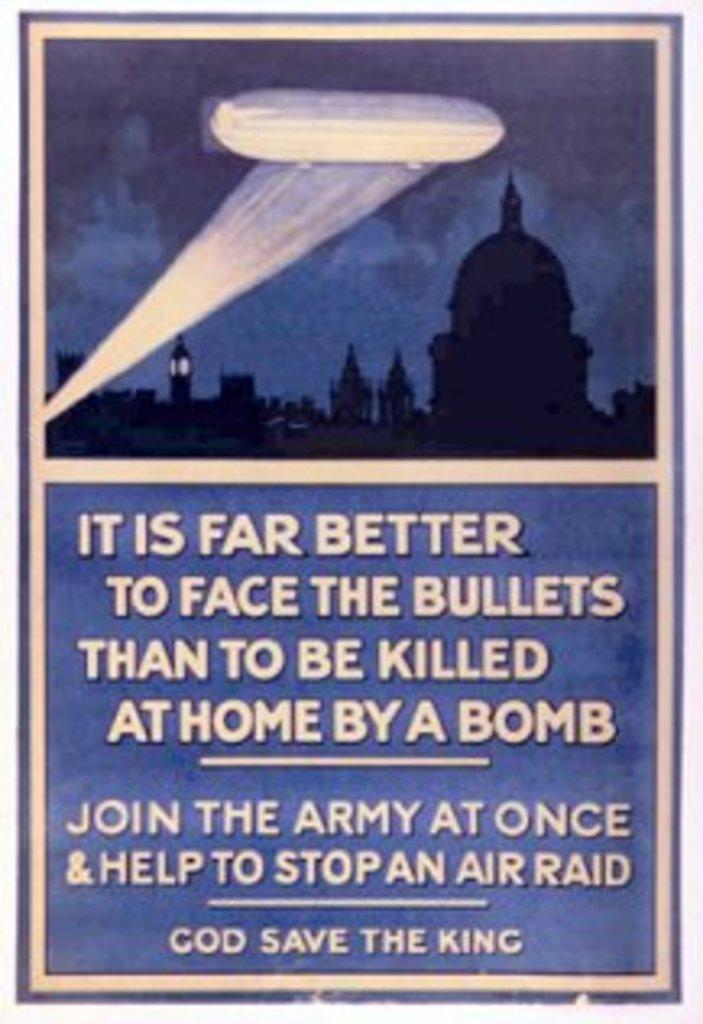Describe this image in one or two sentences. This is a poster. On this poster we can see ancient architecture and text written on it. 